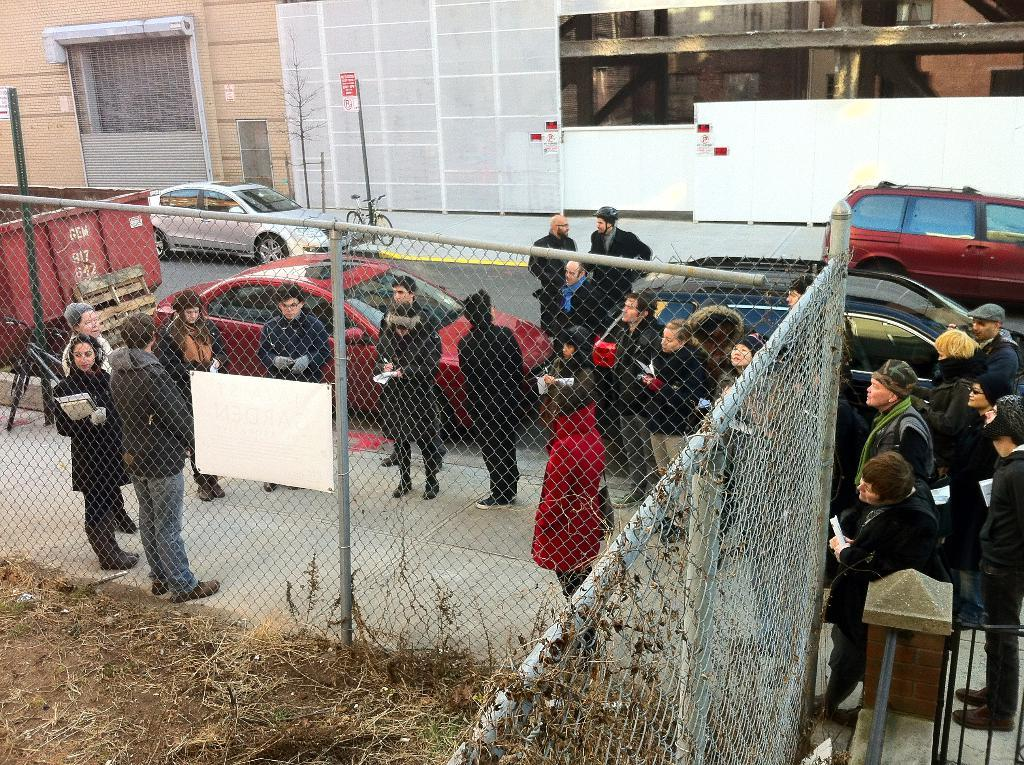What types of objects can be seen in the image? There are vehicles and people on the ground in the image. What is separating the vehicles from the people? There is a fence in the image. What type of terrain is visible in the image? There is grass in the image. What can be seen in the distance in the image? There are buildings in the background of the image. What type of net is being used to catch the flying vehicles in the image? There are no flying vehicles or nets present in the image. 